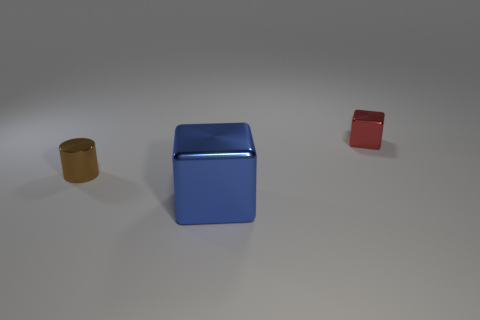Add 3 large yellow balls. How many objects exist? 6 Subtract all blocks. How many objects are left? 1 Subtract 0 gray blocks. How many objects are left? 3 Subtract all brown metal blocks. Subtract all tiny brown metal cylinders. How many objects are left? 2 Add 2 brown cylinders. How many brown cylinders are left? 3 Add 1 large blue shiny cubes. How many large blue shiny cubes exist? 2 